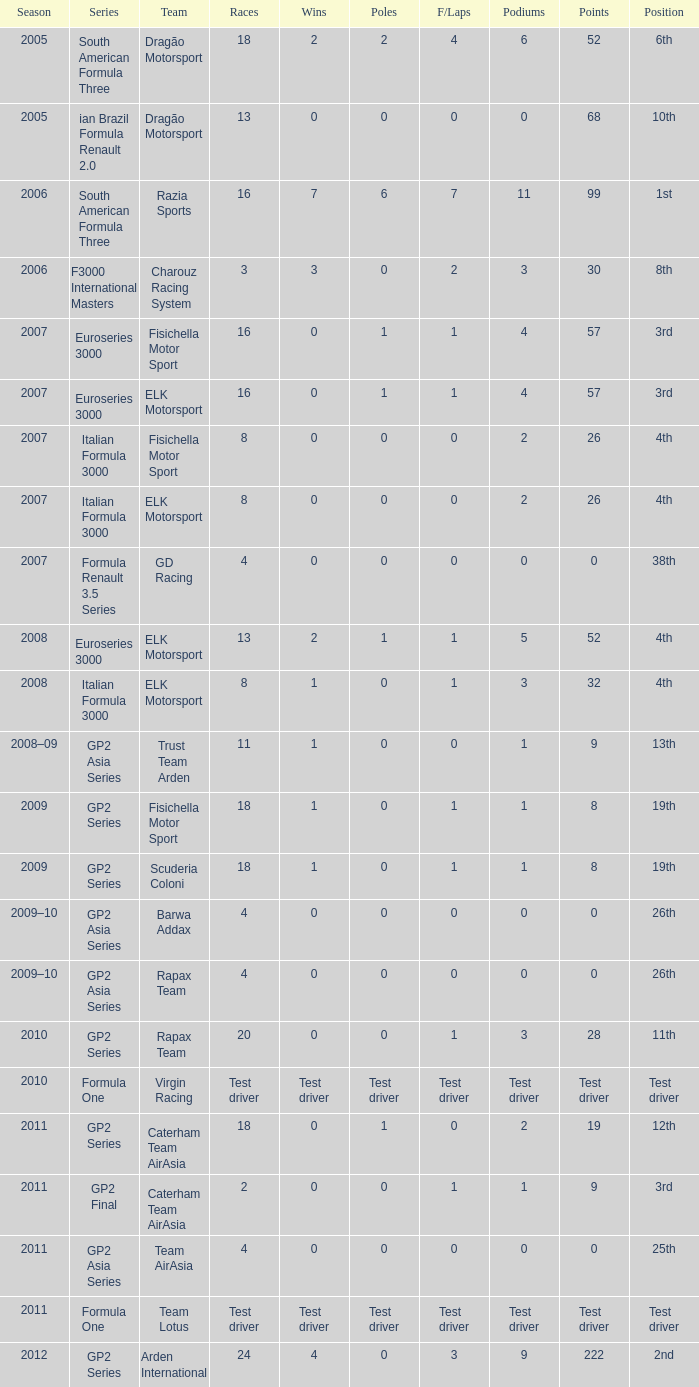What was the F/Laps when the Wins were 0 and the Position was 4th? 0, 0. 